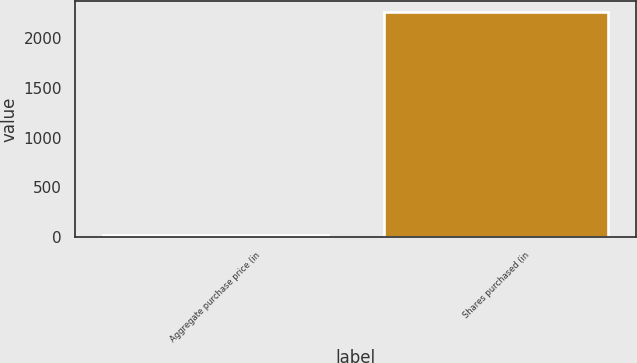Convert chart to OTSL. <chart><loc_0><loc_0><loc_500><loc_500><bar_chart><fcel>Aggregate purchase price (in<fcel>Shares purchased (in<nl><fcel>23<fcel>2262<nl></chart> 